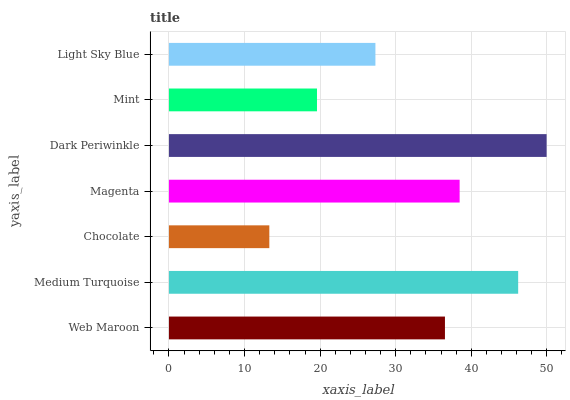Is Chocolate the minimum?
Answer yes or no. Yes. Is Dark Periwinkle the maximum?
Answer yes or no. Yes. Is Medium Turquoise the minimum?
Answer yes or no. No. Is Medium Turquoise the maximum?
Answer yes or no. No. Is Medium Turquoise greater than Web Maroon?
Answer yes or no. Yes. Is Web Maroon less than Medium Turquoise?
Answer yes or no. Yes. Is Web Maroon greater than Medium Turquoise?
Answer yes or no. No. Is Medium Turquoise less than Web Maroon?
Answer yes or no. No. Is Web Maroon the high median?
Answer yes or no. Yes. Is Web Maroon the low median?
Answer yes or no. Yes. Is Magenta the high median?
Answer yes or no. No. Is Dark Periwinkle the low median?
Answer yes or no. No. 